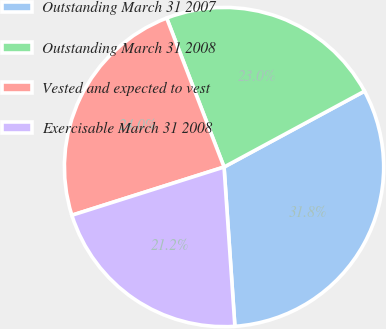Convert chart to OTSL. <chart><loc_0><loc_0><loc_500><loc_500><pie_chart><fcel>Outstanding March 31 2007<fcel>Outstanding March 31 2008<fcel>Vested and expected to vest<fcel>Exercisable March 31 2008<nl><fcel>31.8%<fcel>22.97%<fcel>24.03%<fcel>21.2%<nl></chart> 